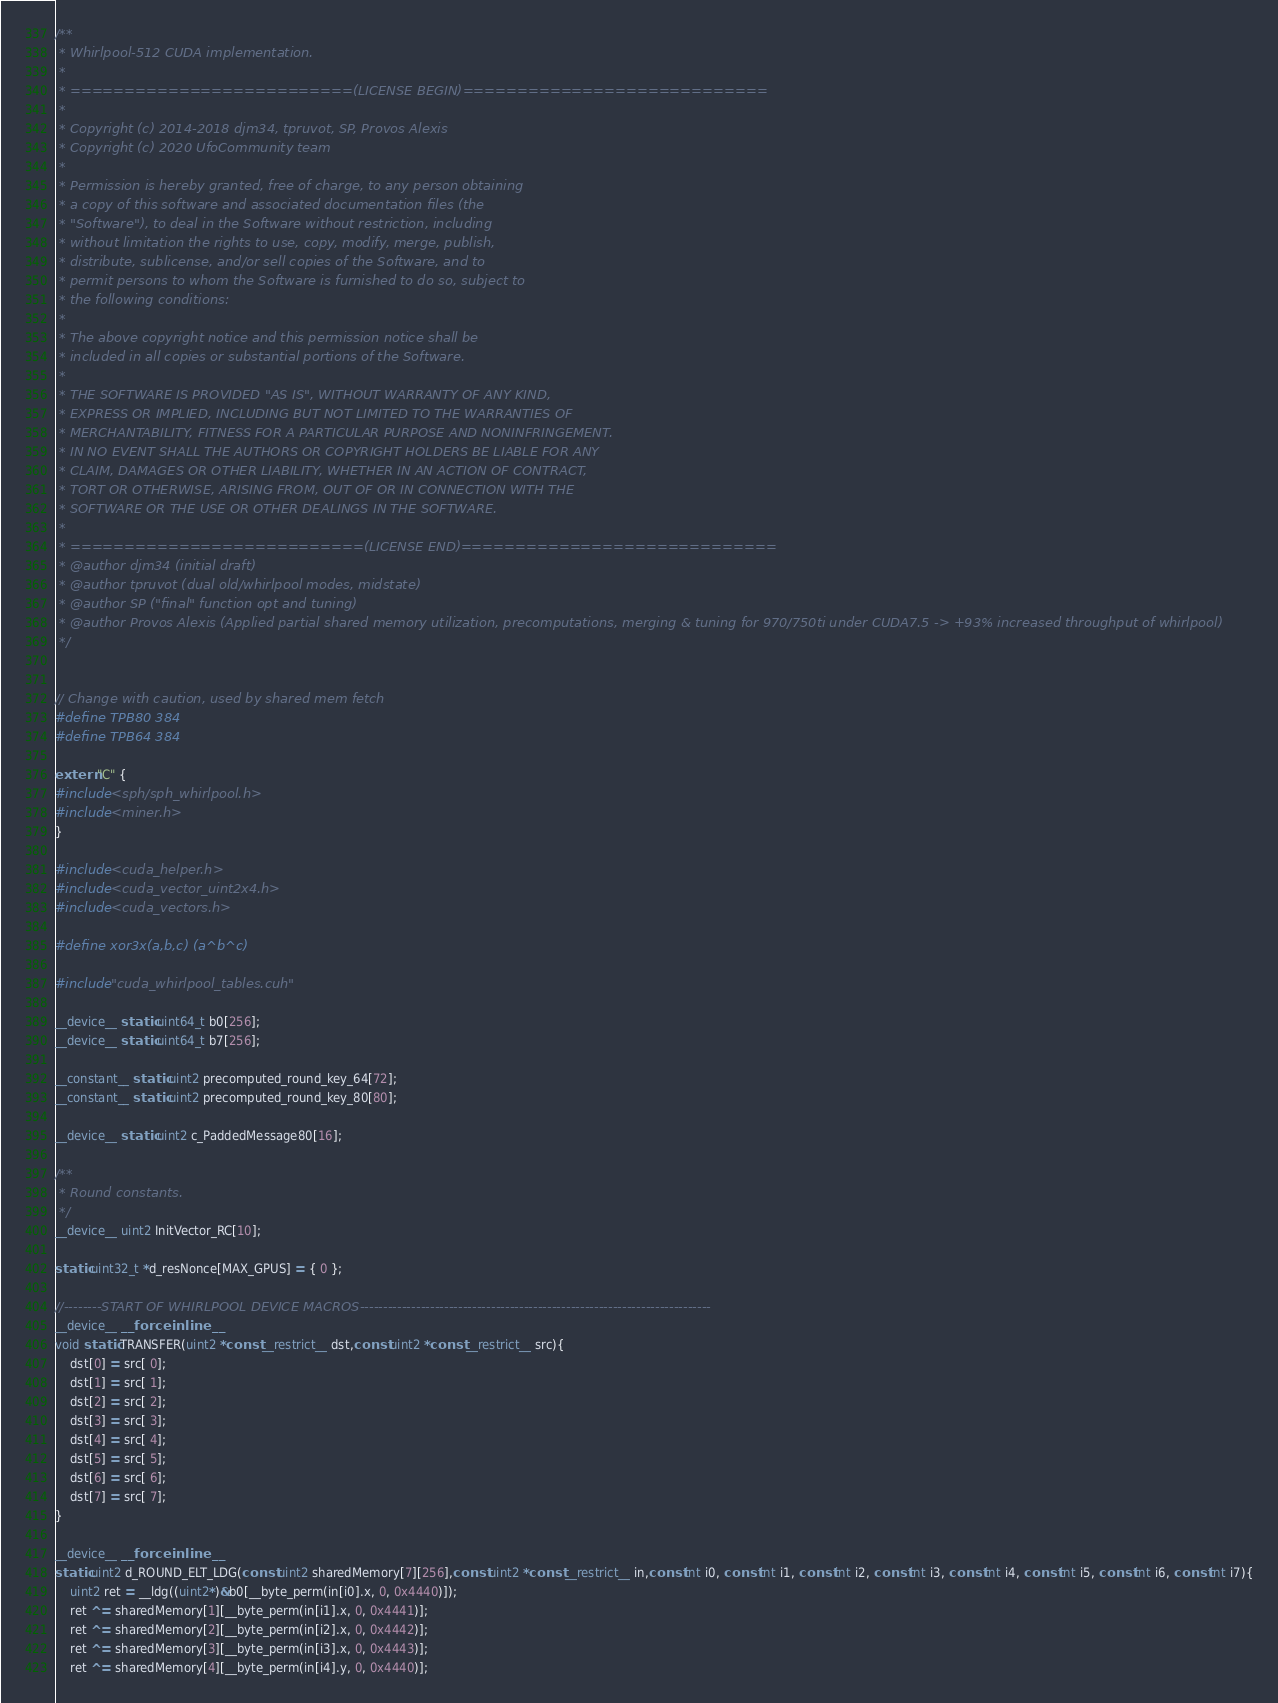<code> <loc_0><loc_0><loc_500><loc_500><_Cuda_>/**
 * Whirlpool-512 CUDA implementation.
 *
 * ==========================(LICENSE BEGIN)============================
 *
 * Copyright (c) 2014-2018 djm34, tpruvot, SP, Provos Alexis
 * Copyright (c) 2020 UfoCommunity team
 *
 * Permission is hereby granted, free of charge, to any person obtaining
 * a copy of this software and associated documentation files (the
 * "Software"), to deal in the Software without restriction, including
 * without limitation the rights to use, copy, modify, merge, publish,
 * distribute, sublicense, and/or sell copies of the Software, and to
 * permit persons to whom the Software is furnished to do so, subject to
 * the following conditions:
 *
 * The above copyright notice and this permission notice shall be
 * included in all copies or substantial portions of the Software.
 *
 * THE SOFTWARE IS PROVIDED "AS IS", WITHOUT WARRANTY OF ANY KIND,
 * EXPRESS OR IMPLIED, INCLUDING BUT NOT LIMITED TO THE WARRANTIES OF
 * MERCHANTABILITY, FITNESS FOR A PARTICULAR PURPOSE AND NONINFRINGEMENT.
 * IN NO EVENT SHALL THE AUTHORS OR COPYRIGHT HOLDERS BE LIABLE FOR ANY
 * CLAIM, DAMAGES OR OTHER LIABILITY, WHETHER IN AN ACTION OF CONTRACT,
 * TORT OR OTHERWISE, ARISING FROM, OUT OF OR IN CONNECTION WITH THE
 * SOFTWARE OR THE USE OR OTHER DEALINGS IN THE SOFTWARE.
 *
 * ===========================(LICENSE END)=============================
 * @author djm34 (initial draft)
 * @author tpruvot (dual old/whirlpool modes, midstate)
 * @author SP ("final" function opt and tuning)
 * @author Provos Alexis (Applied partial shared memory utilization, precomputations, merging & tuning for 970/750ti under CUDA7.5 -> +93% increased throughput of whirlpool)
 */


// Change with caution, used by shared mem fetch
#define TPB80 384
#define TPB64 384

extern "C" {
#include <sph/sph_whirlpool.h>
#include <miner.h>
}

#include <cuda_helper.h>
#include <cuda_vector_uint2x4.h>
#include <cuda_vectors.h>

#define xor3x(a,b,c) (a^b^c)

#include "cuda_whirlpool_tables.cuh"

__device__ static uint64_t b0[256];
__device__ static uint64_t b7[256];

__constant__ static uint2 precomputed_round_key_64[72];
__constant__ static uint2 precomputed_round_key_80[80];

__device__ static uint2 c_PaddedMessage80[16];

/**
 * Round constants.
 */
__device__ uint2 InitVector_RC[10];

static uint32_t *d_resNonce[MAX_GPUS] = { 0 };

//--------START OF WHIRLPOOL DEVICE MACROS---------------------------------------------------------------------------
__device__ __forceinline__
void static TRANSFER(uint2 *const __restrict__ dst,const uint2 *const __restrict__ src){
	dst[0] = src[ 0];
	dst[1] = src[ 1];
	dst[2] = src[ 2];
	dst[3] = src[ 3];
	dst[4] = src[ 4];
	dst[5] = src[ 5];
	dst[6] = src[ 6];
	dst[7] = src[ 7];
}

__device__ __forceinline__
static uint2 d_ROUND_ELT_LDG(const uint2 sharedMemory[7][256],const uint2 *const __restrict__ in,const int i0, const int i1, const int i2, const int i3, const int i4, const int i5, const int i6, const int i7){
	uint2 ret = __ldg((uint2*)&b0[__byte_perm(in[i0].x, 0, 0x4440)]);
	ret ^= sharedMemory[1][__byte_perm(in[i1].x, 0, 0x4441)];
	ret ^= sharedMemory[2][__byte_perm(in[i2].x, 0, 0x4442)];
	ret ^= sharedMemory[3][__byte_perm(in[i3].x, 0, 0x4443)];
	ret ^= sharedMemory[4][__byte_perm(in[i4].y, 0, 0x4440)];</code> 